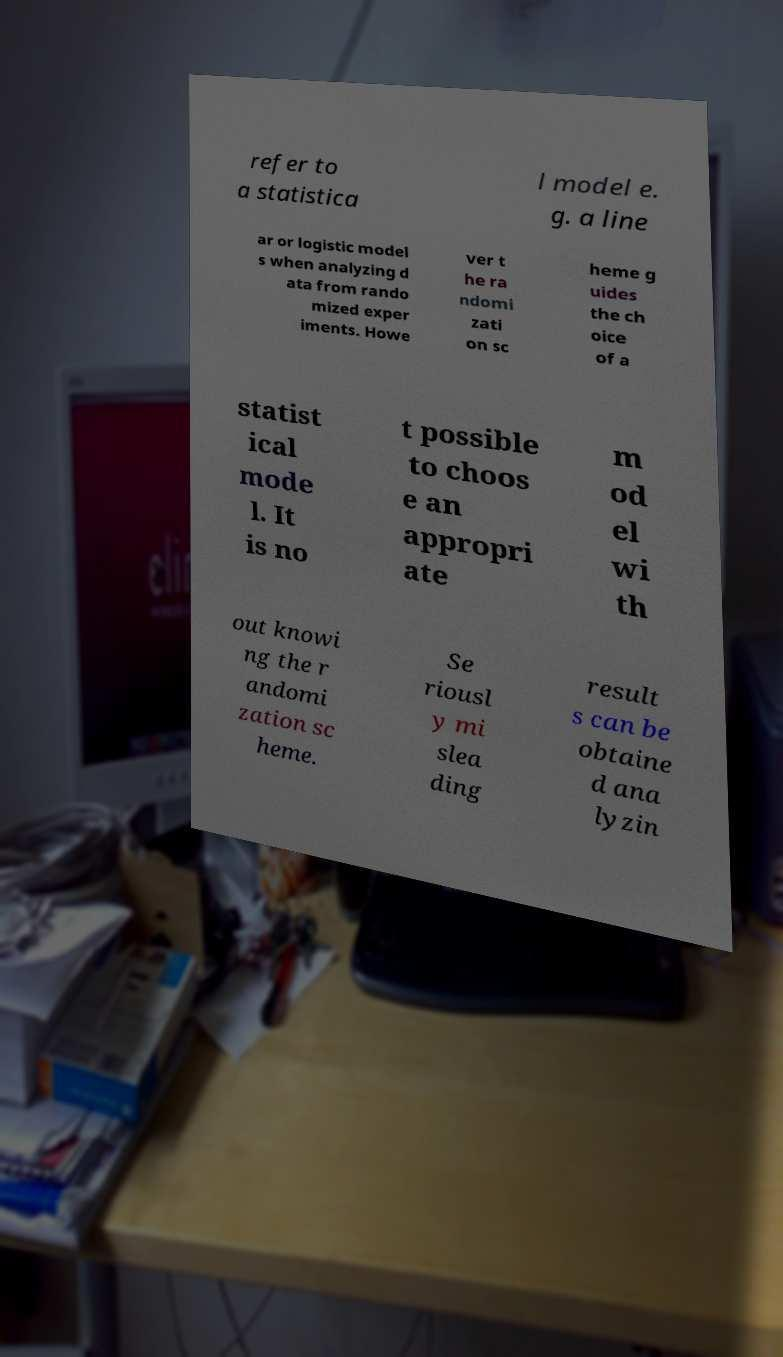There's text embedded in this image that I need extracted. Can you transcribe it verbatim? refer to a statistica l model e. g. a line ar or logistic model s when analyzing d ata from rando mized exper iments. Howe ver t he ra ndomi zati on sc heme g uides the ch oice of a statist ical mode l. It is no t possible to choos e an appropri ate m od el wi th out knowi ng the r andomi zation sc heme. Se riousl y mi slea ding result s can be obtaine d ana lyzin 